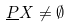<formula> <loc_0><loc_0><loc_500><loc_500>\underline { P } X \ne \emptyset</formula> 